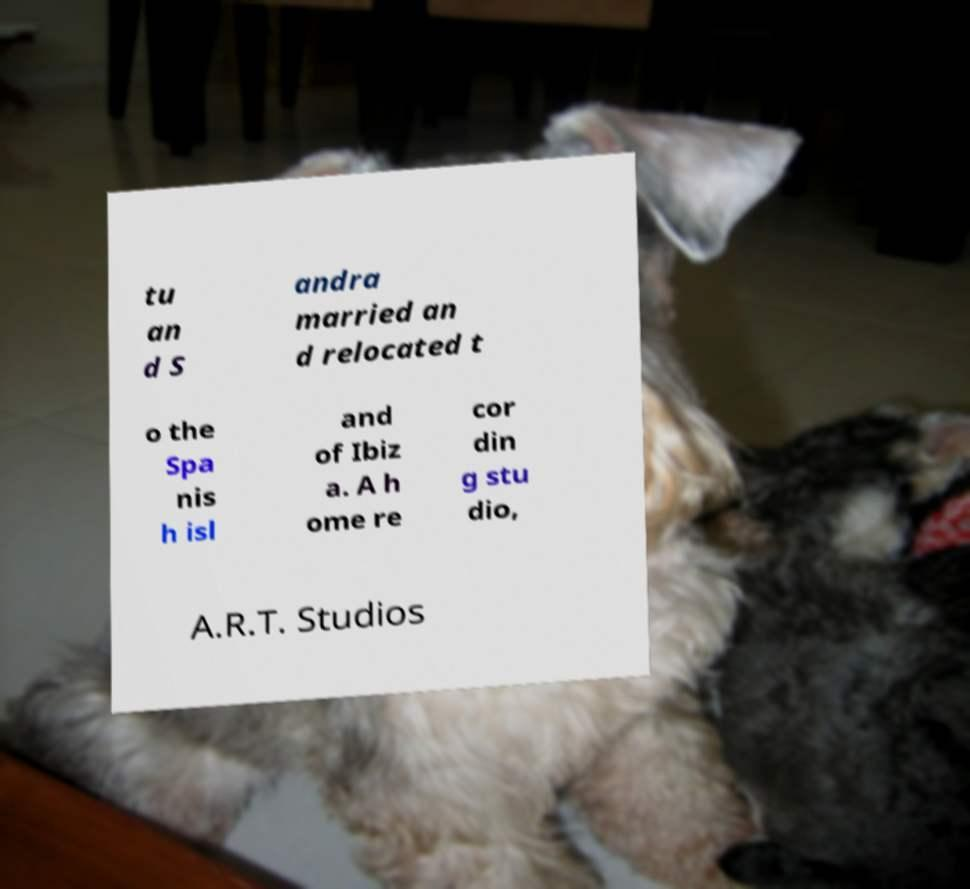What messages or text are displayed in this image? I need them in a readable, typed format. tu an d S andra married an d relocated t o the Spa nis h isl and of Ibiz a. A h ome re cor din g stu dio, A.R.T. Studios 